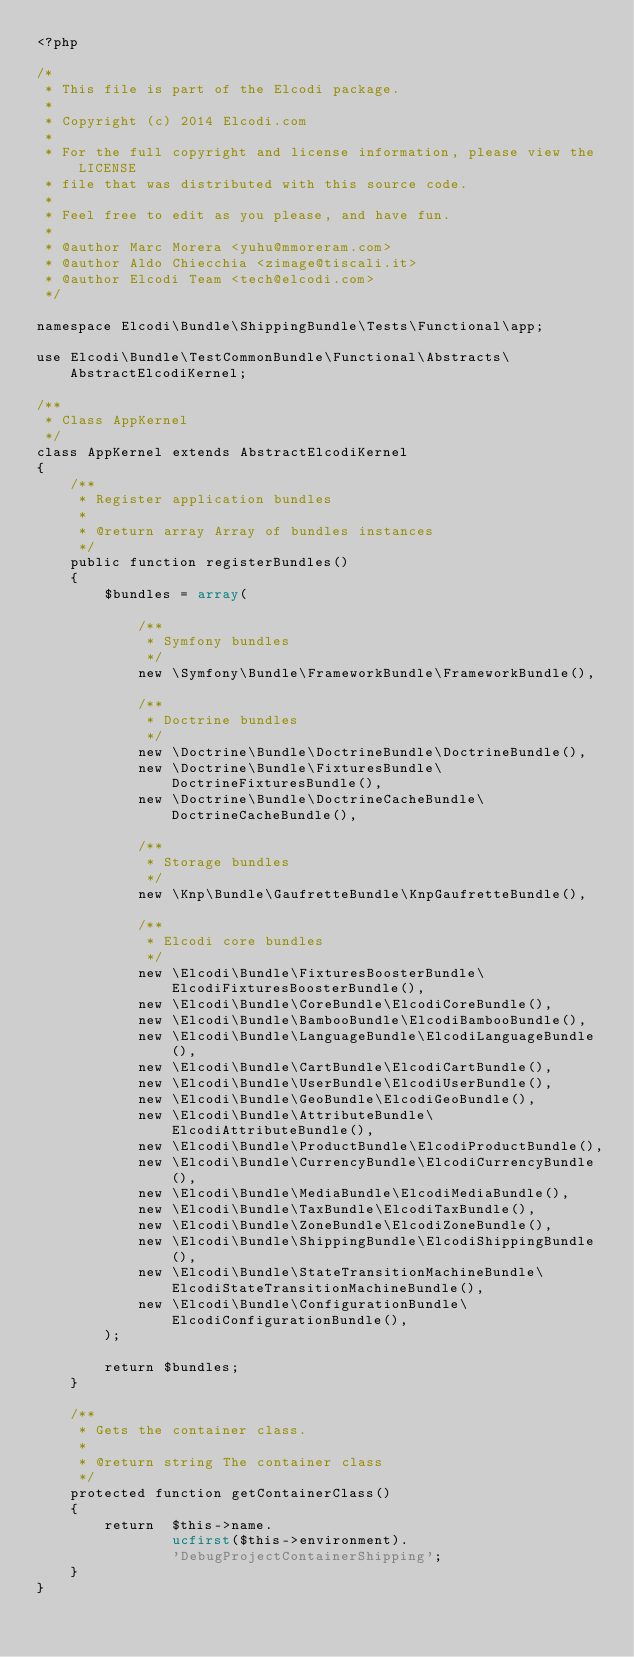Convert code to text. <code><loc_0><loc_0><loc_500><loc_500><_PHP_><?php

/*
 * This file is part of the Elcodi package.
 *
 * Copyright (c) 2014 Elcodi.com
 *
 * For the full copyright and license information, please view the LICENSE
 * file that was distributed with this source code.
 *
 * Feel free to edit as you please, and have fun.
 *
 * @author Marc Morera <yuhu@mmoreram.com>
 * @author Aldo Chiecchia <zimage@tiscali.it>
 * @author Elcodi Team <tech@elcodi.com>
 */

namespace Elcodi\Bundle\ShippingBundle\Tests\Functional\app;

use Elcodi\Bundle\TestCommonBundle\Functional\Abstracts\AbstractElcodiKernel;

/**
 * Class AppKernel
 */
class AppKernel extends AbstractElcodiKernel
{
    /**
     * Register application bundles
     *
     * @return array Array of bundles instances
     */
    public function registerBundles()
    {
        $bundles = array(

            /**
             * Symfony bundles
             */
            new \Symfony\Bundle\FrameworkBundle\FrameworkBundle(),

            /**
             * Doctrine bundles
             */
            new \Doctrine\Bundle\DoctrineBundle\DoctrineBundle(),
            new \Doctrine\Bundle\FixturesBundle\DoctrineFixturesBundle(),
            new \Doctrine\Bundle\DoctrineCacheBundle\DoctrineCacheBundle(),

            /**
             * Storage bundles
             */
            new \Knp\Bundle\GaufretteBundle\KnpGaufretteBundle(),

            /**
             * Elcodi core bundles
             */
            new \Elcodi\Bundle\FixturesBoosterBundle\ElcodiFixturesBoosterBundle(),
            new \Elcodi\Bundle\CoreBundle\ElcodiCoreBundle(),
            new \Elcodi\Bundle\BambooBundle\ElcodiBambooBundle(),
            new \Elcodi\Bundle\LanguageBundle\ElcodiLanguageBundle(),
            new \Elcodi\Bundle\CartBundle\ElcodiCartBundle(),
            new \Elcodi\Bundle\UserBundle\ElcodiUserBundle(),
            new \Elcodi\Bundle\GeoBundle\ElcodiGeoBundle(),
            new \Elcodi\Bundle\AttributeBundle\ElcodiAttributeBundle(),
            new \Elcodi\Bundle\ProductBundle\ElcodiProductBundle(),
            new \Elcodi\Bundle\CurrencyBundle\ElcodiCurrencyBundle(),
            new \Elcodi\Bundle\MediaBundle\ElcodiMediaBundle(),
            new \Elcodi\Bundle\TaxBundle\ElcodiTaxBundle(),
            new \Elcodi\Bundle\ZoneBundle\ElcodiZoneBundle(),
            new \Elcodi\Bundle\ShippingBundle\ElcodiShippingBundle(),
            new \Elcodi\Bundle\StateTransitionMachineBundle\ElcodiStateTransitionMachineBundle(),
            new \Elcodi\Bundle\ConfigurationBundle\ElcodiConfigurationBundle(),
        );

        return $bundles;
    }

    /**
     * Gets the container class.
     *
     * @return string The container class
     */
    protected function getContainerClass()
    {
        return  $this->name.
                ucfirst($this->environment).
                'DebugProjectContainerShipping';
    }
}
</code> 